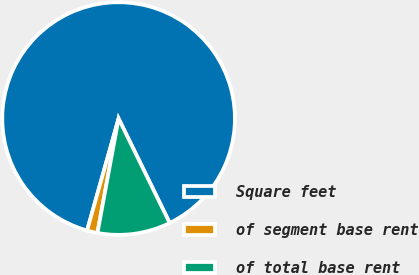Convert chart. <chart><loc_0><loc_0><loc_500><loc_500><pie_chart><fcel>Square feet<fcel>of segment base rent<fcel>of total base rent<nl><fcel>88.39%<fcel>1.46%<fcel>10.15%<nl></chart> 